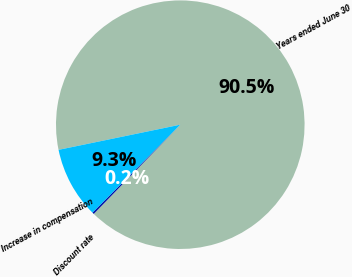Convert chart. <chart><loc_0><loc_0><loc_500><loc_500><pie_chart><fcel>Years ended June 30<fcel>Discount rate<fcel>Increase in compensation<nl><fcel>90.5%<fcel>0.24%<fcel>9.26%<nl></chart> 